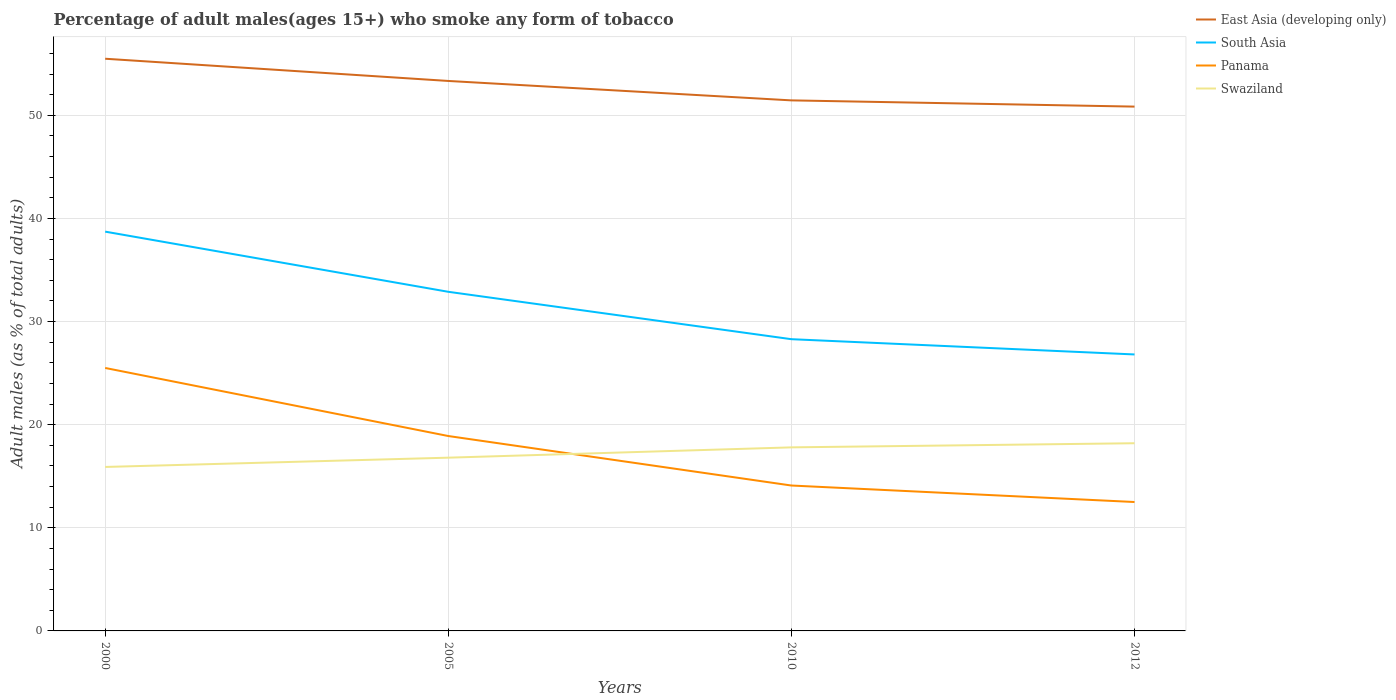How many different coloured lines are there?
Provide a short and direct response. 4. Does the line corresponding to Panama intersect with the line corresponding to East Asia (developing only)?
Make the answer very short. No. Across all years, what is the maximum percentage of adult males who smoke in Swaziland?
Keep it short and to the point. 15.9. In which year was the percentage of adult males who smoke in Swaziland maximum?
Make the answer very short. 2000. What is the total percentage of adult males who smoke in Swaziland in the graph?
Give a very brief answer. -1.4. What is the difference between the highest and the second highest percentage of adult males who smoke in Swaziland?
Your answer should be very brief. 2.3. Is the percentage of adult males who smoke in East Asia (developing only) strictly greater than the percentage of adult males who smoke in Panama over the years?
Ensure brevity in your answer.  No. Where does the legend appear in the graph?
Make the answer very short. Top right. How many legend labels are there?
Make the answer very short. 4. How are the legend labels stacked?
Make the answer very short. Vertical. What is the title of the graph?
Offer a terse response. Percentage of adult males(ages 15+) who smoke any form of tobacco. What is the label or title of the Y-axis?
Your answer should be compact. Adult males (as % of total adults). What is the Adult males (as % of total adults) of East Asia (developing only) in 2000?
Your response must be concise. 55.49. What is the Adult males (as % of total adults) of South Asia in 2000?
Give a very brief answer. 38.72. What is the Adult males (as % of total adults) in Panama in 2000?
Your response must be concise. 25.5. What is the Adult males (as % of total adults) of East Asia (developing only) in 2005?
Ensure brevity in your answer.  53.33. What is the Adult males (as % of total adults) of South Asia in 2005?
Give a very brief answer. 32.89. What is the Adult males (as % of total adults) of Panama in 2005?
Your answer should be compact. 18.9. What is the Adult males (as % of total adults) in East Asia (developing only) in 2010?
Provide a short and direct response. 51.45. What is the Adult males (as % of total adults) of South Asia in 2010?
Make the answer very short. 28.29. What is the Adult males (as % of total adults) in Panama in 2010?
Keep it short and to the point. 14.1. What is the Adult males (as % of total adults) of Swaziland in 2010?
Your response must be concise. 17.8. What is the Adult males (as % of total adults) of East Asia (developing only) in 2012?
Make the answer very short. 50.84. What is the Adult males (as % of total adults) in South Asia in 2012?
Offer a very short reply. 26.81. What is the Adult males (as % of total adults) in Swaziland in 2012?
Ensure brevity in your answer.  18.2. Across all years, what is the maximum Adult males (as % of total adults) of East Asia (developing only)?
Keep it short and to the point. 55.49. Across all years, what is the maximum Adult males (as % of total adults) of South Asia?
Your answer should be very brief. 38.72. Across all years, what is the maximum Adult males (as % of total adults) of Panama?
Your answer should be compact. 25.5. Across all years, what is the maximum Adult males (as % of total adults) in Swaziland?
Offer a terse response. 18.2. Across all years, what is the minimum Adult males (as % of total adults) of East Asia (developing only)?
Your response must be concise. 50.84. Across all years, what is the minimum Adult males (as % of total adults) in South Asia?
Your answer should be compact. 26.81. Across all years, what is the minimum Adult males (as % of total adults) of Panama?
Keep it short and to the point. 12.5. What is the total Adult males (as % of total adults) of East Asia (developing only) in the graph?
Give a very brief answer. 211.11. What is the total Adult males (as % of total adults) of South Asia in the graph?
Make the answer very short. 126.71. What is the total Adult males (as % of total adults) of Swaziland in the graph?
Offer a terse response. 68.7. What is the difference between the Adult males (as % of total adults) of East Asia (developing only) in 2000 and that in 2005?
Your answer should be very brief. 2.15. What is the difference between the Adult males (as % of total adults) in South Asia in 2000 and that in 2005?
Your response must be concise. 5.83. What is the difference between the Adult males (as % of total adults) in Panama in 2000 and that in 2005?
Give a very brief answer. 6.6. What is the difference between the Adult males (as % of total adults) of Swaziland in 2000 and that in 2005?
Offer a terse response. -0.9. What is the difference between the Adult males (as % of total adults) in East Asia (developing only) in 2000 and that in 2010?
Your answer should be compact. 4.04. What is the difference between the Adult males (as % of total adults) of South Asia in 2000 and that in 2010?
Keep it short and to the point. 10.43. What is the difference between the Adult males (as % of total adults) of East Asia (developing only) in 2000 and that in 2012?
Offer a very short reply. 4.64. What is the difference between the Adult males (as % of total adults) of South Asia in 2000 and that in 2012?
Offer a very short reply. 11.91. What is the difference between the Adult males (as % of total adults) of Swaziland in 2000 and that in 2012?
Make the answer very short. -2.3. What is the difference between the Adult males (as % of total adults) in East Asia (developing only) in 2005 and that in 2010?
Ensure brevity in your answer.  1.88. What is the difference between the Adult males (as % of total adults) in South Asia in 2005 and that in 2010?
Provide a short and direct response. 4.6. What is the difference between the Adult males (as % of total adults) in Panama in 2005 and that in 2010?
Offer a terse response. 4.8. What is the difference between the Adult males (as % of total adults) in East Asia (developing only) in 2005 and that in 2012?
Offer a very short reply. 2.49. What is the difference between the Adult males (as % of total adults) of South Asia in 2005 and that in 2012?
Your answer should be very brief. 6.08. What is the difference between the Adult males (as % of total adults) of Swaziland in 2005 and that in 2012?
Your answer should be very brief. -1.4. What is the difference between the Adult males (as % of total adults) in East Asia (developing only) in 2010 and that in 2012?
Provide a succinct answer. 0.6. What is the difference between the Adult males (as % of total adults) of South Asia in 2010 and that in 2012?
Your response must be concise. 1.48. What is the difference between the Adult males (as % of total adults) in Panama in 2010 and that in 2012?
Provide a succinct answer. 1.6. What is the difference between the Adult males (as % of total adults) in East Asia (developing only) in 2000 and the Adult males (as % of total adults) in South Asia in 2005?
Make the answer very short. 22.6. What is the difference between the Adult males (as % of total adults) in East Asia (developing only) in 2000 and the Adult males (as % of total adults) in Panama in 2005?
Provide a short and direct response. 36.59. What is the difference between the Adult males (as % of total adults) of East Asia (developing only) in 2000 and the Adult males (as % of total adults) of Swaziland in 2005?
Provide a succinct answer. 38.69. What is the difference between the Adult males (as % of total adults) in South Asia in 2000 and the Adult males (as % of total adults) in Panama in 2005?
Your response must be concise. 19.82. What is the difference between the Adult males (as % of total adults) of South Asia in 2000 and the Adult males (as % of total adults) of Swaziland in 2005?
Provide a succinct answer. 21.92. What is the difference between the Adult males (as % of total adults) of East Asia (developing only) in 2000 and the Adult males (as % of total adults) of South Asia in 2010?
Offer a very short reply. 27.2. What is the difference between the Adult males (as % of total adults) in East Asia (developing only) in 2000 and the Adult males (as % of total adults) in Panama in 2010?
Offer a very short reply. 41.39. What is the difference between the Adult males (as % of total adults) in East Asia (developing only) in 2000 and the Adult males (as % of total adults) in Swaziland in 2010?
Provide a succinct answer. 37.69. What is the difference between the Adult males (as % of total adults) in South Asia in 2000 and the Adult males (as % of total adults) in Panama in 2010?
Your answer should be very brief. 24.62. What is the difference between the Adult males (as % of total adults) in South Asia in 2000 and the Adult males (as % of total adults) in Swaziland in 2010?
Give a very brief answer. 20.92. What is the difference between the Adult males (as % of total adults) in East Asia (developing only) in 2000 and the Adult males (as % of total adults) in South Asia in 2012?
Provide a short and direct response. 28.68. What is the difference between the Adult males (as % of total adults) in East Asia (developing only) in 2000 and the Adult males (as % of total adults) in Panama in 2012?
Your response must be concise. 42.99. What is the difference between the Adult males (as % of total adults) in East Asia (developing only) in 2000 and the Adult males (as % of total adults) in Swaziland in 2012?
Provide a short and direct response. 37.29. What is the difference between the Adult males (as % of total adults) in South Asia in 2000 and the Adult males (as % of total adults) in Panama in 2012?
Provide a succinct answer. 26.22. What is the difference between the Adult males (as % of total adults) of South Asia in 2000 and the Adult males (as % of total adults) of Swaziland in 2012?
Offer a terse response. 20.52. What is the difference between the Adult males (as % of total adults) in East Asia (developing only) in 2005 and the Adult males (as % of total adults) in South Asia in 2010?
Offer a very short reply. 25.04. What is the difference between the Adult males (as % of total adults) in East Asia (developing only) in 2005 and the Adult males (as % of total adults) in Panama in 2010?
Ensure brevity in your answer.  39.23. What is the difference between the Adult males (as % of total adults) in East Asia (developing only) in 2005 and the Adult males (as % of total adults) in Swaziland in 2010?
Your answer should be very brief. 35.53. What is the difference between the Adult males (as % of total adults) of South Asia in 2005 and the Adult males (as % of total adults) of Panama in 2010?
Your answer should be compact. 18.79. What is the difference between the Adult males (as % of total adults) in South Asia in 2005 and the Adult males (as % of total adults) in Swaziland in 2010?
Provide a succinct answer. 15.09. What is the difference between the Adult males (as % of total adults) of East Asia (developing only) in 2005 and the Adult males (as % of total adults) of South Asia in 2012?
Your answer should be very brief. 26.52. What is the difference between the Adult males (as % of total adults) of East Asia (developing only) in 2005 and the Adult males (as % of total adults) of Panama in 2012?
Your response must be concise. 40.83. What is the difference between the Adult males (as % of total adults) of East Asia (developing only) in 2005 and the Adult males (as % of total adults) of Swaziland in 2012?
Make the answer very short. 35.13. What is the difference between the Adult males (as % of total adults) of South Asia in 2005 and the Adult males (as % of total adults) of Panama in 2012?
Make the answer very short. 20.39. What is the difference between the Adult males (as % of total adults) in South Asia in 2005 and the Adult males (as % of total adults) in Swaziland in 2012?
Ensure brevity in your answer.  14.69. What is the difference between the Adult males (as % of total adults) of East Asia (developing only) in 2010 and the Adult males (as % of total adults) of South Asia in 2012?
Offer a terse response. 24.64. What is the difference between the Adult males (as % of total adults) in East Asia (developing only) in 2010 and the Adult males (as % of total adults) in Panama in 2012?
Give a very brief answer. 38.95. What is the difference between the Adult males (as % of total adults) in East Asia (developing only) in 2010 and the Adult males (as % of total adults) in Swaziland in 2012?
Keep it short and to the point. 33.25. What is the difference between the Adult males (as % of total adults) in South Asia in 2010 and the Adult males (as % of total adults) in Panama in 2012?
Keep it short and to the point. 15.79. What is the difference between the Adult males (as % of total adults) of South Asia in 2010 and the Adult males (as % of total adults) of Swaziland in 2012?
Make the answer very short. 10.09. What is the difference between the Adult males (as % of total adults) in Panama in 2010 and the Adult males (as % of total adults) in Swaziland in 2012?
Offer a very short reply. -4.1. What is the average Adult males (as % of total adults) in East Asia (developing only) per year?
Your answer should be very brief. 52.78. What is the average Adult males (as % of total adults) of South Asia per year?
Offer a terse response. 31.68. What is the average Adult males (as % of total adults) of Panama per year?
Offer a very short reply. 17.75. What is the average Adult males (as % of total adults) of Swaziland per year?
Provide a short and direct response. 17.18. In the year 2000, what is the difference between the Adult males (as % of total adults) in East Asia (developing only) and Adult males (as % of total adults) in South Asia?
Give a very brief answer. 16.77. In the year 2000, what is the difference between the Adult males (as % of total adults) of East Asia (developing only) and Adult males (as % of total adults) of Panama?
Provide a succinct answer. 29.99. In the year 2000, what is the difference between the Adult males (as % of total adults) in East Asia (developing only) and Adult males (as % of total adults) in Swaziland?
Your answer should be compact. 39.59. In the year 2000, what is the difference between the Adult males (as % of total adults) of South Asia and Adult males (as % of total adults) of Panama?
Offer a terse response. 13.22. In the year 2000, what is the difference between the Adult males (as % of total adults) in South Asia and Adult males (as % of total adults) in Swaziland?
Give a very brief answer. 22.82. In the year 2005, what is the difference between the Adult males (as % of total adults) of East Asia (developing only) and Adult males (as % of total adults) of South Asia?
Your response must be concise. 20.45. In the year 2005, what is the difference between the Adult males (as % of total adults) in East Asia (developing only) and Adult males (as % of total adults) in Panama?
Your answer should be compact. 34.43. In the year 2005, what is the difference between the Adult males (as % of total adults) in East Asia (developing only) and Adult males (as % of total adults) in Swaziland?
Make the answer very short. 36.53. In the year 2005, what is the difference between the Adult males (as % of total adults) in South Asia and Adult males (as % of total adults) in Panama?
Offer a very short reply. 13.99. In the year 2005, what is the difference between the Adult males (as % of total adults) of South Asia and Adult males (as % of total adults) of Swaziland?
Make the answer very short. 16.09. In the year 2005, what is the difference between the Adult males (as % of total adults) in Panama and Adult males (as % of total adults) in Swaziland?
Your response must be concise. 2.1. In the year 2010, what is the difference between the Adult males (as % of total adults) in East Asia (developing only) and Adult males (as % of total adults) in South Asia?
Provide a short and direct response. 23.16. In the year 2010, what is the difference between the Adult males (as % of total adults) in East Asia (developing only) and Adult males (as % of total adults) in Panama?
Your answer should be compact. 37.35. In the year 2010, what is the difference between the Adult males (as % of total adults) of East Asia (developing only) and Adult males (as % of total adults) of Swaziland?
Your response must be concise. 33.65. In the year 2010, what is the difference between the Adult males (as % of total adults) in South Asia and Adult males (as % of total adults) in Panama?
Keep it short and to the point. 14.19. In the year 2010, what is the difference between the Adult males (as % of total adults) in South Asia and Adult males (as % of total adults) in Swaziland?
Offer a terse response. 10.49. In the year 2012, what is the difference between the Adult males (as % of total adults) of East Asia (developing only) and Adult males (as % of total adults) of South Asia?
Your answer should be compact. 24.03. In the year 2012, what is the difference between the Adult males (as % of total adults) in East Asia (developing only) and Adult males (as % of total adults) in Panama?
Give a very brief answer. 38.34. In the year 2012, what is the difference between the Adult males (as % of total adults) in East Asia (developing only) and Adult males (as % of total adults) in Swaziland?
Make the answer very short. 32.64. In the year 2012, what is the difference between the Adult males (as % of total adults) in South Asia and Adult males (as % of total adults) in Panama?
Offer a terse response. 14.31. In the year 2012, what is the difference between the Adult males (as % of total adults) in South Asia and Adult males (as % of total adults) in Swaziland?
Your response must be concise. 8.61. What is the ratio of the Adult males (as % of total adults) of East Asia (developing only) in 2000 to that in 2005?
Offer a very short reply. 1.04. What is the ratio of the Adult males (as % of total adults) of South Asia in 2000 to that in 2005?
Keep it short and to the point. 1.18. What is the ratio of the Adult males (as % of total adults) in Panama in 2000 to that in 2005?
Offer a terse response. 1.35. What is the ratio of the Adult males (as % of total adults) in Swaziland in 2000 to that in 2005?
Make the answer very short. 0.95. What is the ratio of the Adult males (as % of total adults) of East Asia (developing only) in 2000 to that in 2010?
Offer a terse response. 1.08. What is the ratio of the Adult males (as % of total adults) of South Asia in 2000 to that in 2010?
Ensure brevity in your answer.  1.37. What is the ratio of the Adult males (as % of total adults) in Panama in 2000 to that in 2010?
Your answer should be compact. 1.81. What is the ratio of the Adult males (as % of total adults) of Swaziland in 2000 to that in 2010?
Your response must be concise. 0.89. What is the ratio of the Adult males (as % of total adults) of East Asia (developing only) in 2000 to that in 2012?
Keep it short and to the point. 1.09. What is the ratio of the Adult males (as % of total adults) of South Asia in 2000 to that in 2012?
Keep it short and to the point. 1.44. What is the ratio of the Adult males (as % of total adults) of Panama in 2000 to that in 2012?
Your answer should be very brief. 2.04. What is the ratio of the Adult males (as % of total adults) in Swaziland in 2000 to that in 2012?
Offer a very short reply. 0.87. What is the ratio of the Adult males (as % of total adults) in East Asia (developing only) in 2005 to that in 2010?
Make the answer very short. 1.04. What is the ratio of the Adult males (as % of total adults) of South Asia in 2005 to that in 2010?
Provide a short and direct response. 1.16. What is the ratio of the Adult males (as % of total adults) of Panama in 2005 to that in 2010?
Ensure brevity in your answer.  1.34. What is the ratio of the Adult males (as % of total adults) of Swaziland in 2005 to that in 2010?
Offer a terse response. 0.94. What is the ratio of the Adult males (as % of total adults) of East Asia (developing only) in 2005 to that in 2012?
Offer a terse response. 1.05. What is the ratio of the Adult males (as % of total adults) of South Asia in 2005 to that in 2012?
Offer a very short reply. 1.23. What is the ratio of the Adult males (as % of total adults) of Panama in 2005 to that in 2012?
Give a very brief answer. 1.51. What is the ratio of the Adult males (as % of total adults) in Swaziland in 2005 to that in 2012?
Provide a short and direct response. 0.92. What is the ratio of the Adult males (as % of total adults) in East Asia (developing only) in 2010 to that in 2012?
Your answer should be very brief. 1.01. What is the ratio of the Adult males (as % of total adults) in South Asia in 2010 to that in 2012?
Ensure brevity in your answer.  1.06. What is the ratio of the Adult males (as % of total adults) in Panama in 2010 to that in 2012?
Make the answer very short. 1.13. What is the ratio of the Adult males (as % of total adults) in Swaziland in 2010 to that in 2012?
Ensure brevity in your answer.  0.98. What is the difference between the highest and the second highest Adult males (as % of total adults) of East Asia (developing only)?
Provide a short and direct response. 2.15. What is the difference between the highest and the second highest Adult males (as % of total adults) of South Asia?
Offer a very short reply. 5.83. What is the difference between the highest and the lowest Adult males (as % of total adults) in East Asia (developing only)?
Make the answer very short. 4.64. What is the difference between the highest and the lowest Adult males (as % of total adults) of South Asia?
Ensure brevity in your answer.  11.91. What is the difference between the highest and the lowest Adult males (as % of total adults) in Panama?
Your answer should be very brief. 13. What is the difference between the highest and the lowest Adult males (as % of total adults) of Swaziland?
Offer a terse response. 2.3. 